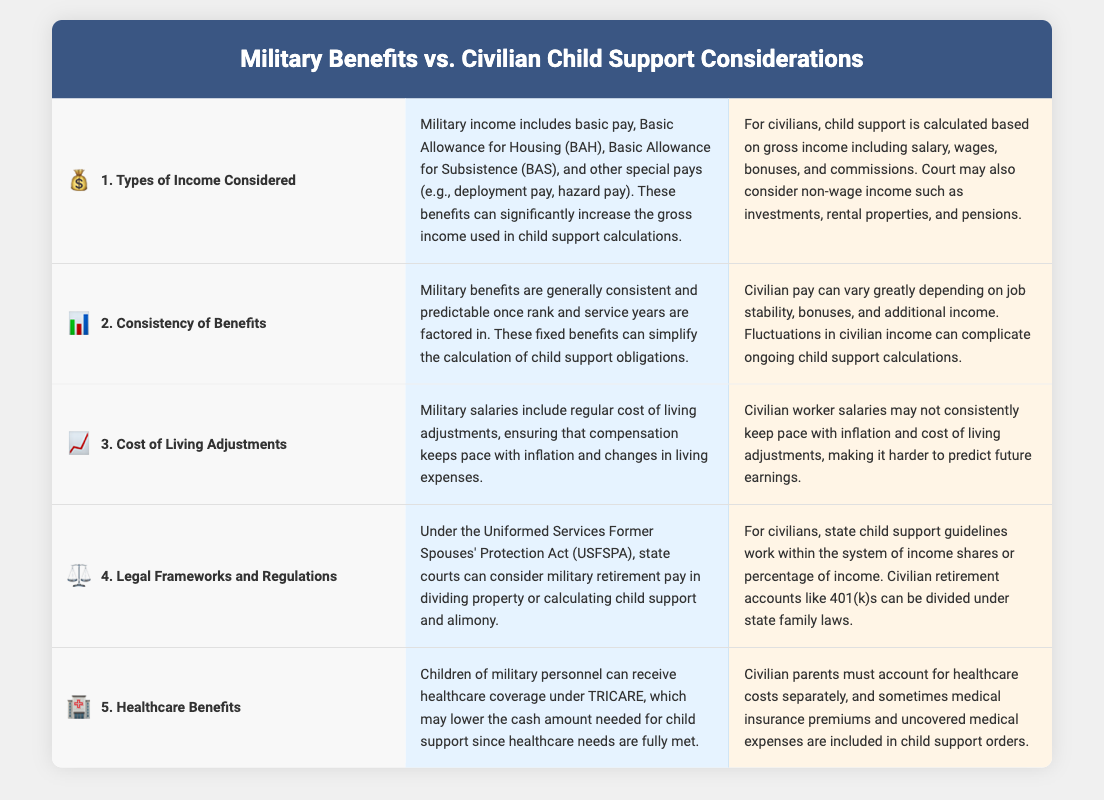What types of income are included in military child support calculations? The document states that military income includes basic pay, Basic Allowance for Housing (BAH), Basic Allowance for Subsistence (BAS), and other special pays.
Answer: basic pay, BAH, BAS, special pays How does military income consistency compare to civilian income? The document mentions that military benefits are generally consistent and predictable, while civilian income can vary greatly.
Answer: military benefits are consistent What act allows state courts to consider military retirement pay? The document specifies that the Uniformed Services Former Spouses' Protection Act (USFSPA) allows this consideration.
Answer: USFSPA What costs do civilian parents have to account for separately compared to military families? The document states that civilian parents must account for healthcare costs separately, unlike military families who have TRICARE coverage.
Answer: healthcare costs Which group benefits from healthcare coverage under TRICARE? The document indicates that children of military personnel can receive healthcare coverage under TRICARE.
Answer: children of military personnel In terms of stability, how do military benefits and civilian pay differ? The document describes military benefits as fixed and predictable, while civilian pay can fluctuate due to job stability and bonuses.
Answer: military pay is fixed What is a key difference in cost of living adjustments between military and civilian salaries? According to the document, military salaries include regular cost of living adjustments, while civilian salaries may not consistently keep pace.
Answer: military salaries have adjustments Which benefits can complicate civilian child support calculations? The document states that fluctuations in civilian income can complicate ongoing child support calculations.
Answer: fluctuations in income 